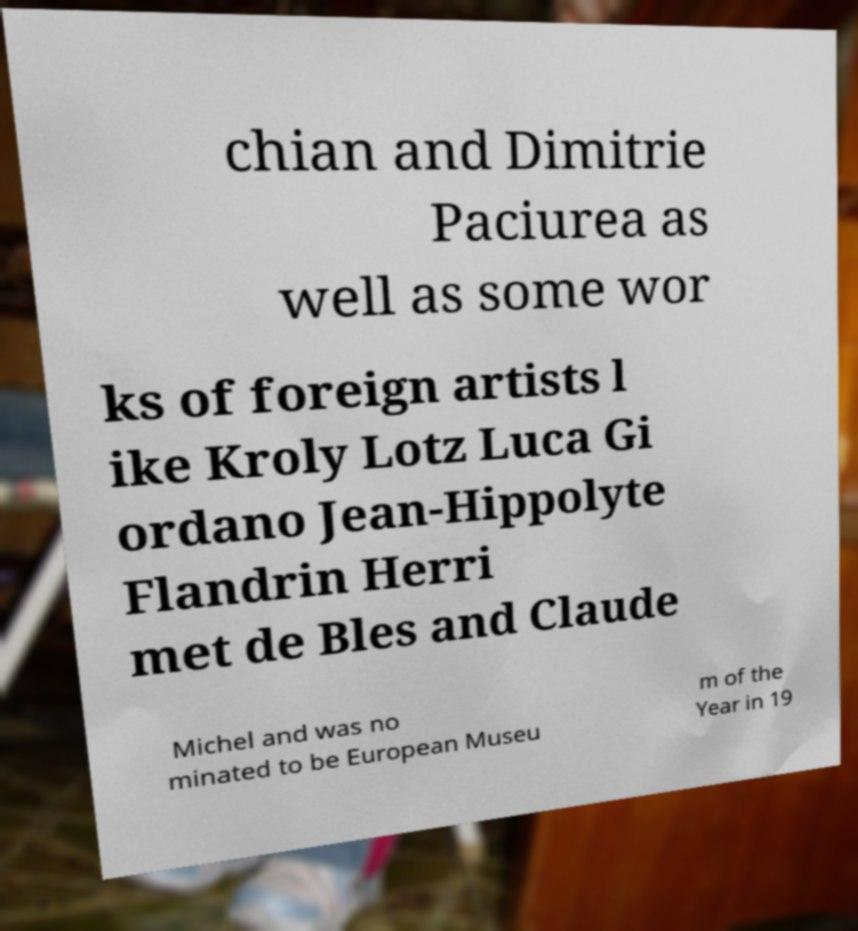Can you accurately transcribe the text from the provided image for me? chian and Dimitrie Paciurea as well as some wor ks of foreign artists l ike Kroly Lotz Luca Gi ordano Jean-Hippolyte Flandrin Herri met de Bles and Claude Michel and was no minated to be European Museu m of the Year in 19 